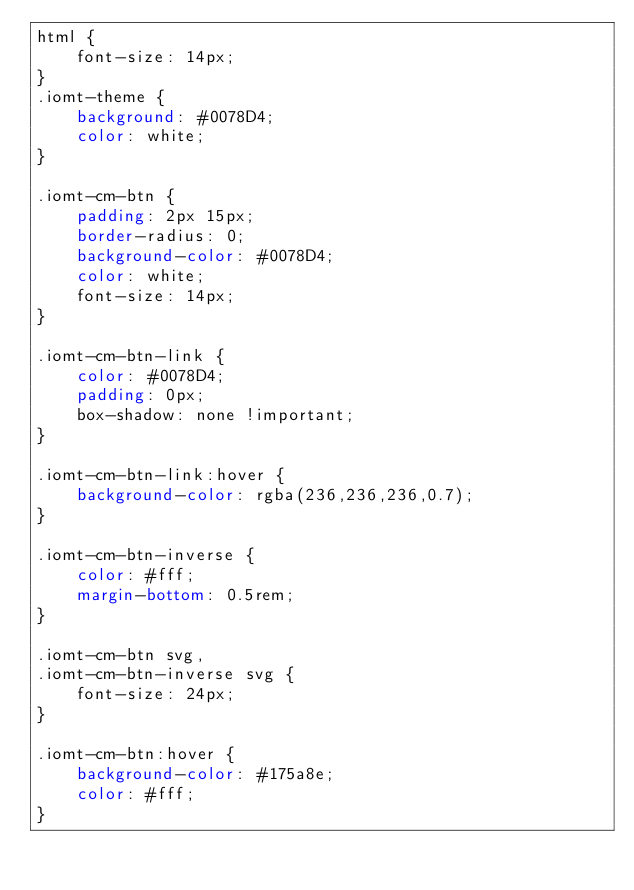<code> <loc_0><loc_0><loc_500><loc_500><_CSS_>html {
    font-size: 14px;
}
.iomt-theme {
    background: #0078D4;
    color: white;
}

.iomt-cm-btn {
    padding: 2px 15px;
    border-radius: 0;
    background-color: #0078D4;
    color: white;
    font-size: 14px;
}

.iomt-cm-btn-link {
    color: #0078D4;
    padding: 0px;
    box-shadow: none !important;
}

.iomt-cm-btn-link:hover {
    background-color: rgba(236,236,236,0.7);
}

.iomt-cm-btn-inverse {
    color: #fff;
    margin-bottom: 0.5rem;
}

.iomt-cm-btn svg,
.iomt-cm-btn-inverse svg {
    font-size: 24px;
}

.iomt-cm-btn:hover {
    background-color: #175a8e;
    color: #fff;
}</code> 